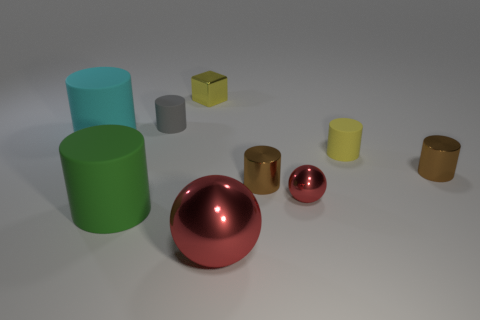How many other things are made of the same material as the small gray cylinder?
Make the answer very short. 3. There is a big metallic sphere; is its color the same as the sphere that is on the right side of the big red sphere?
Ensure brevity in your answer.  Yes. Is the number of cyan rubber objects that are on the left side of the big red ball greater than the number of tiny purple metal balls?
Make the answer very short. Yes. There is a tiny cylinder behind the rubber thing that is on the right side of the big shiny sphere; what number of tiny red things are right of it?
Offer a very short reply. 1. Does the matte thing that is behind the big cyan object have the same shape as the cyan thing?
Offer a terse response. Yes. There is a small object on the left side of the small yellow metal thing; what material is it?
Keep it short and to the point. Rubber. There is a thing that is both in front of the small red metallic thing and to the right of the tiny yellow metallic object; what is its shape?
Make the answer very short. Sphere. What is the material of the small red sphere?
Your response must be concise. Metal. How many blocks are either gray rubber things or blue objects?
Keep it short and to the point. 0. Is the material of the yellow cube the same as the green cylinder?
Keep it short and to the point. No. 